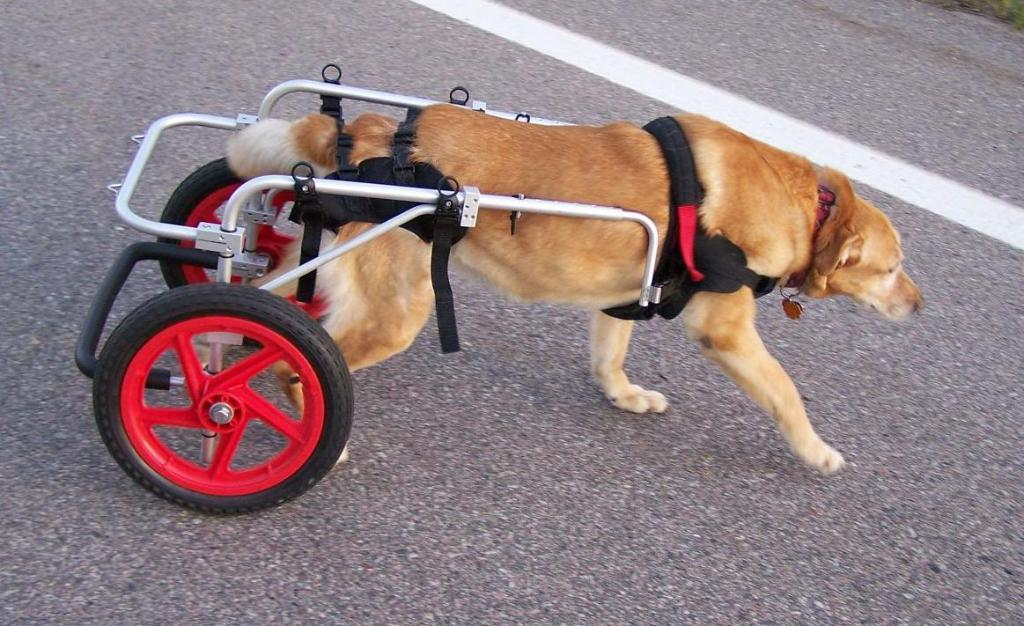What type of animal is present in the image? There is a dog in the image. Where is the dog located? The dog is on a road in the image. What additional feature is connected to the dog? There are two wheels connected to the dog in the image. What type of fiction is the dog reading during the meeting in the image? There is no fiction or meeting present in the image; it features a dog with two wheels on a road. 